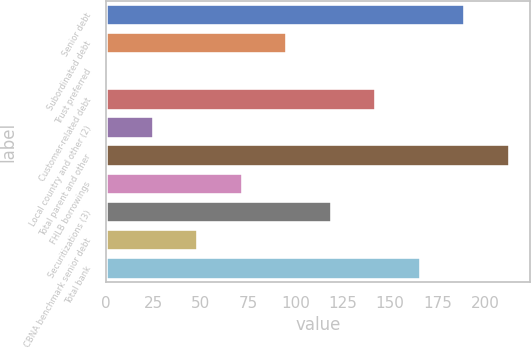Convert chart to OTSL. <chart><loc_0><loc_0><loc_500><loc_500><bar_chart><fcel>Senior debt<fcel>Subordinated debt<fcel>Trust preferred<fcel>Customer-related debt<fcel>Local country and other (2)<fcel>Total parent and other<fcel>FHLB borrowings<fcel>Securitizations (3)<fcel>CBNA benchmark senior debt<fcel>Total bank<nl><fcel>189.7<fcel>95.7<fcel>1.7<fcel>142.7<fcel>25.2<fcel>213.2<fcel>72.2<fcel>119.2<fcel>48.7<fcel>166.2<nl></chart> 